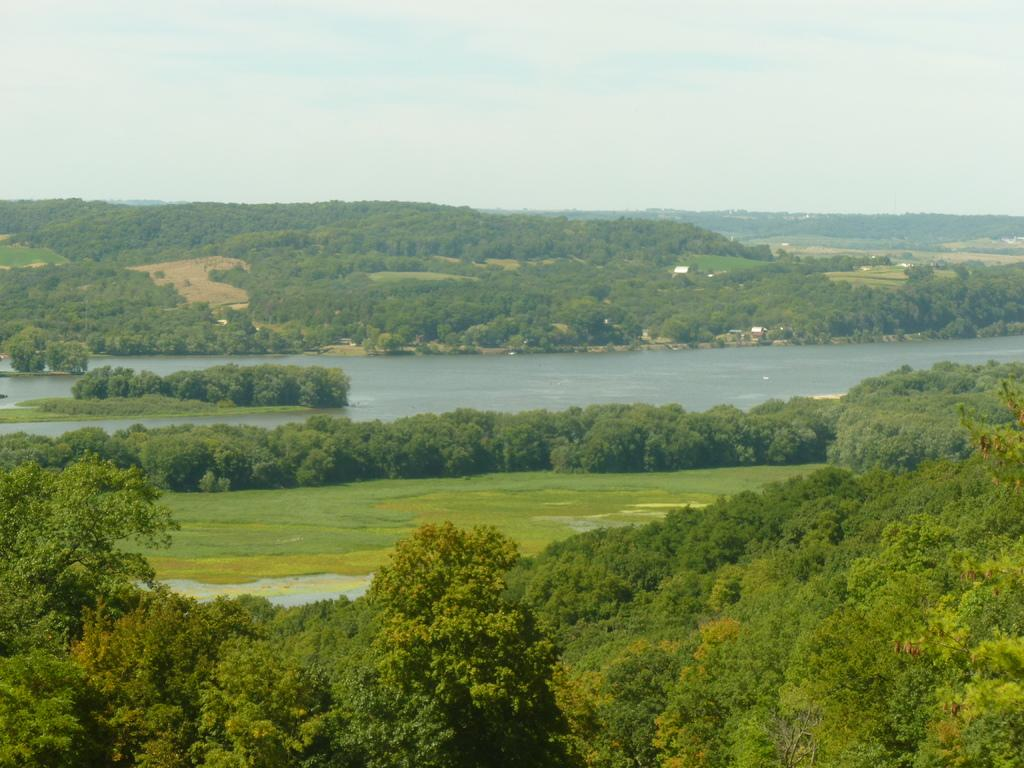What can be seen in the image that is not solid? There is water visible in the image. What type of vegetation is present in the image? There is a group of trees in the image. What is visible at the top of the image? The sky is visible at the top of the image. What is the dad's favorite color in the image? There is no dad present in the image, so it is not possible to determine his favorite color. 